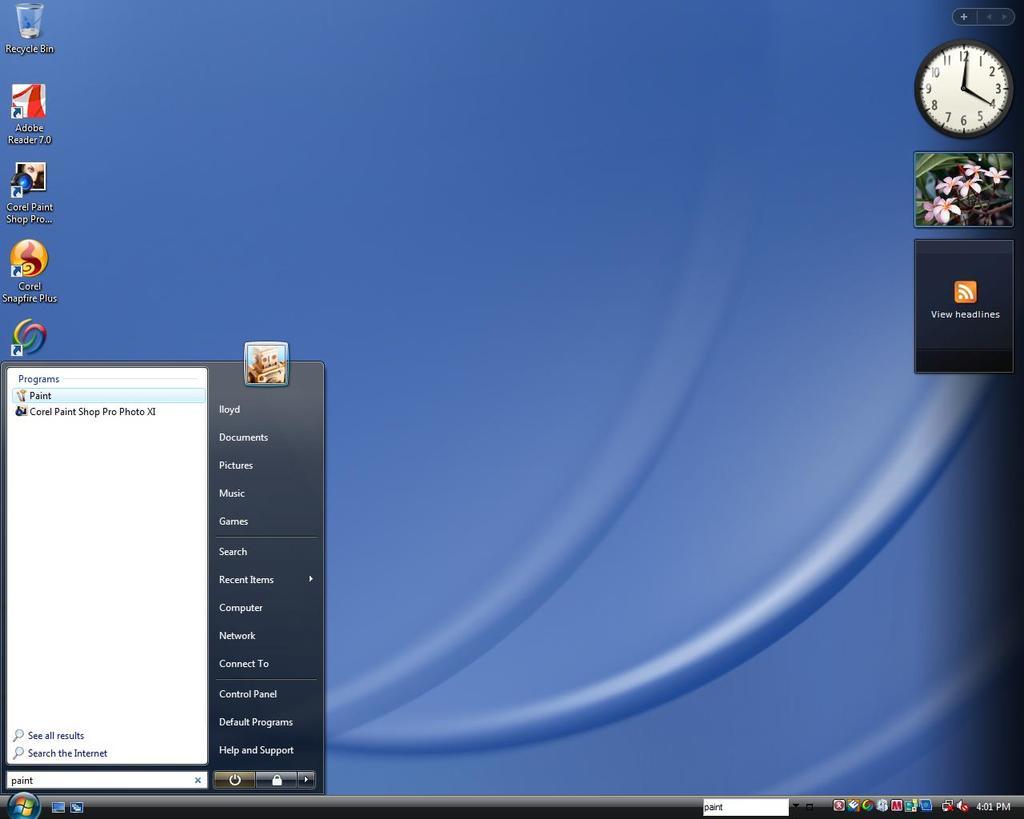What is the name of the upper most icon on the left?
Offer a very short reply. Recycle bin. What is the name of the person who owns this account on this computer?
Your answer should be very brief. Unanswerable. 